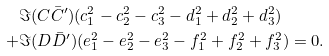<formula> <loc_0><loc_0><loc_500><loc_500>& \Im ( C \bar { C } ^ { \prime } ) ( c _ { 1 } ^ { 2 } - c _ { 2 } ^ { 2 } - c _ { 3 } ^ { 2 } - d _ { 1 } ^ { 2 } + d _ { 2 } ^ { 2 } + d _ { 3 } ^ { 2 } ) \\ + & \Im ( D \bar { D } ^ { \prime } ) ( e _ { 1 } ^ { 2 } - e _ { 2 } ^ { 2 } - e _ { 3 } ^ { 2 } - f _ { 1 } ^ { 2 } + f _ { 2 } ^ { 2 } + f _ { 3 } ^ { 2 } ) = 0 .</formula> 